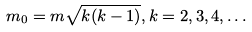<formula> <loc_0><loc_0><loc_500><loc_500>m _ { 0 } = m \sqrt { k ( k - 1 ) } , k = 2 , 3 , 4 , \dots</formula> 